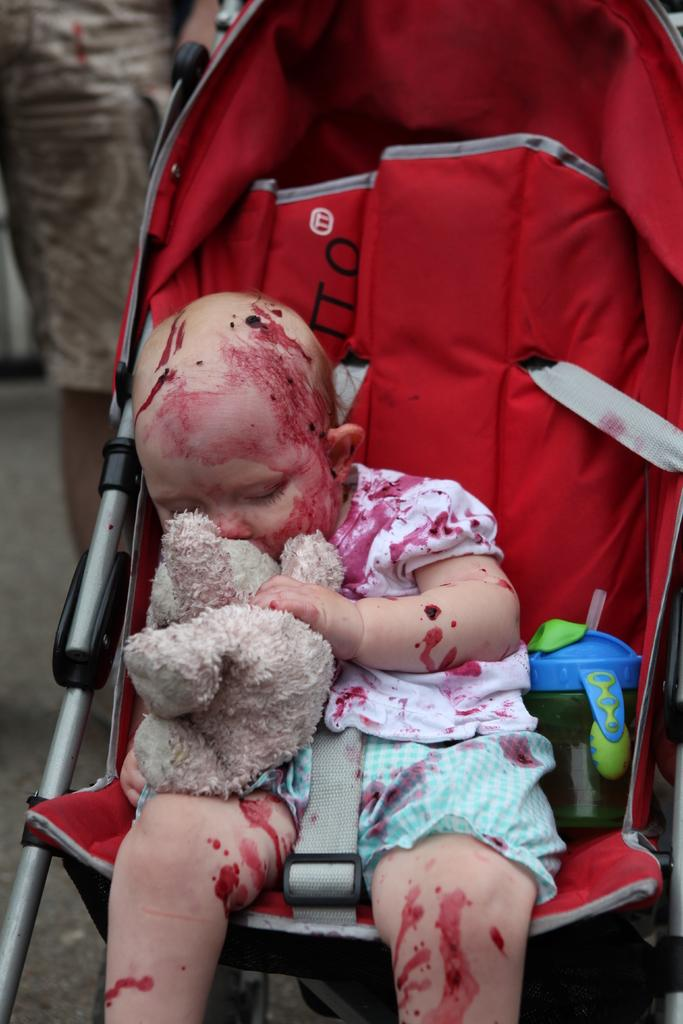What is the main subject of the image? There is a baby in the image. What is the baby holding in the image? The baby is holding a toy. What is the baby sitting on in the image? The baby is sitting on a walker. Is there any liquid or food item visible in the image? Yes, there is a water bottle beside the baby. What type of guitar is the baby playing in the image? There is no guitar present in the image; the baby is holding a toy. What type of soup is the baby eating in the image? There is no soup present in the image; the baby is holding a toy and sitting on a walker. 